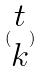Convert formula to latex. <formula><loc_0><loc_0><loc_500><loc_500>( \begin{matrix} t \\ k \end{matrix} )</formula> 